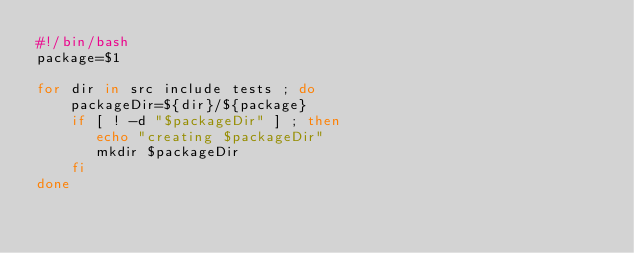<code> <loc_0><loc_0><loc_500><loc_500><_Bash_>#!/bin/bash
package=$1

for dir in src include tests ; do
    packageDir=${dir}/${package}
    if [ ! -d "$packageDir" ] ; then
       echo "creating $packageDir"
       mkdir $packageDir
    fi
done

</code> 